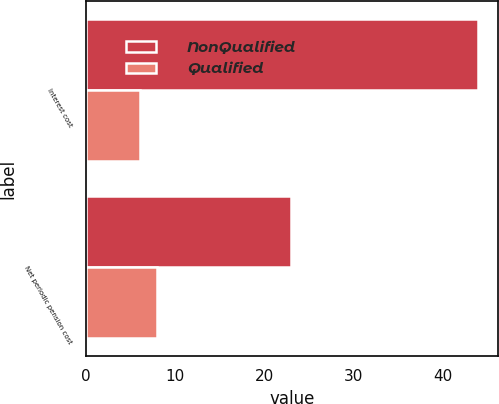Convert chart to OTSL. <chart><loc_0><loc_0><loc_500><loc_500><stacked_bar_chart><ecel><fcel>Interest cost<fcel>Net periodic pension cost<nl><fcel>NonQualified<fcel>44<fcel>23<nl><fcel>Qualified<fcel>6<fcel>8<nl></chart> 